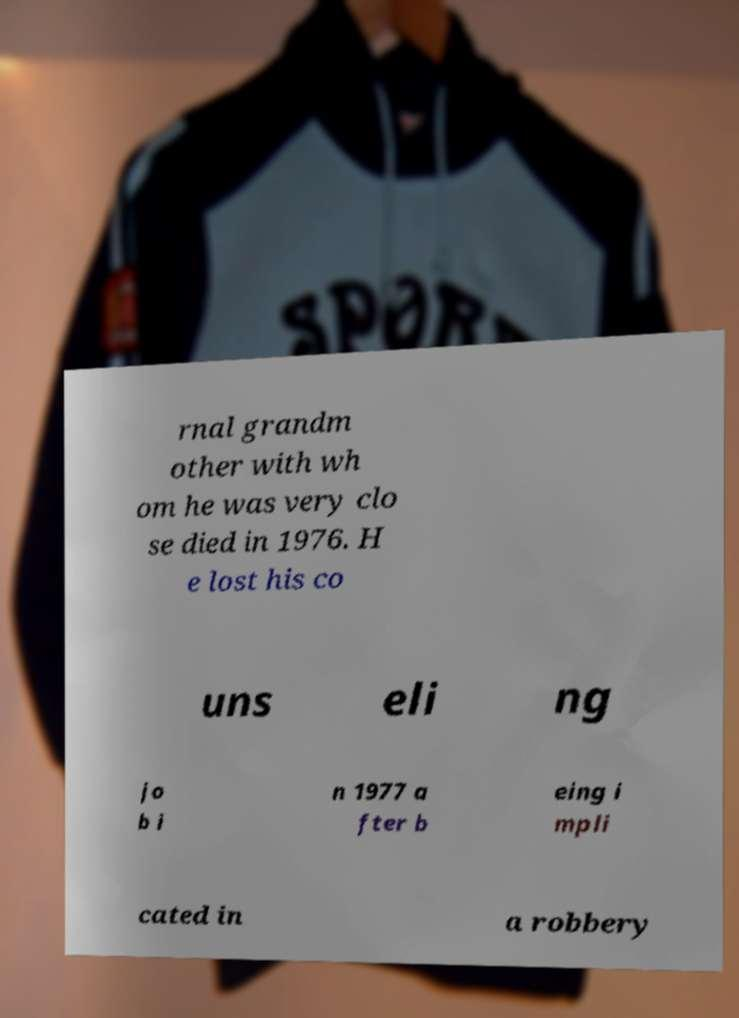I need the written content from this picture converted into text. Can you do that? rnal grandm other with wh om he was very clo se died in 1976. H e lost his co uns eli ng jo b i n 1977 a fter b eing i mpli cated in a robbery 